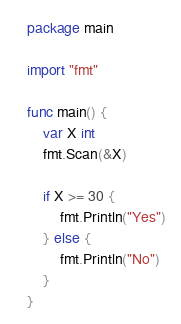Convert code to text. <code><loc_0><loc_0><loc_500><loc_500><_Go_>package main

import "fmt"

func main() {
	var X int
	fmt.Scan(&X)

	if X >= 30 {
		fmt.Println("Yes")
	} else {
		fmt.Println("No")
	}
}
</code> 